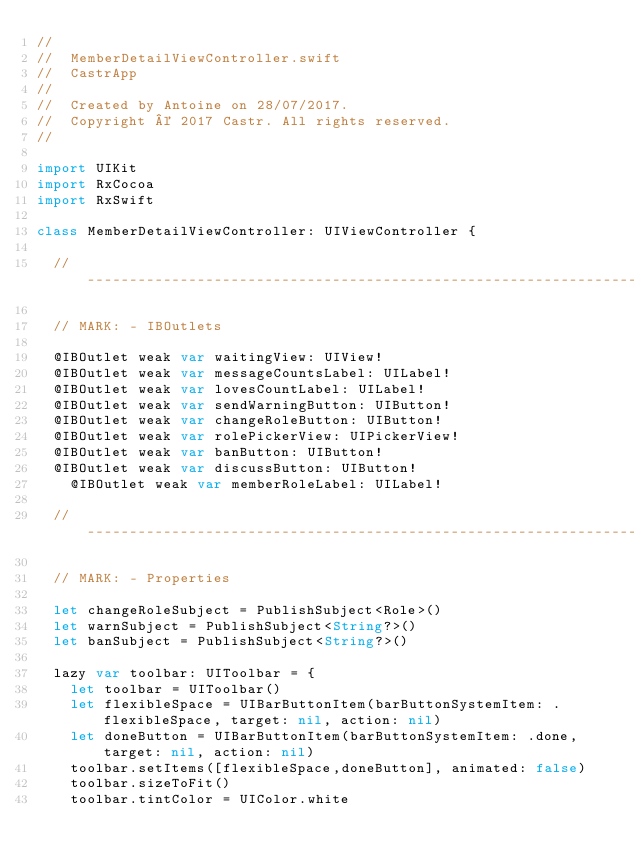<code> <loc_0><loc_0><loc_500><loc_500><_Swift_>//
//  MemberDetailViewController.swift
//  CastrApp
//
//  Created by Antoine on 28/07/2017.
//  Copyright © 2017 Castr. All rights reserved.
//

import UIKit
import RxCocoa
import RxSwift

class MemberDetailViewController: UIViewController {
  
  // -----------------------------------------------------------------------------------------------
  
  // MARK: - IBOutlets
    
  @IBOutlet weak var waitingView: UIView!
  @IBOutlet weak var messageCountsLabel: UILabel!
  @IBOutlet weak var lovesCountLabel: UILabel!
  @IBOutlet weak var sendWarningButton: UIButton!
  @IBOutlet weak var changeRoleButton: UIButton!
  @IBOutlet weak var rolePickerView: UIPickerView!
  @IBOutlet weak var banButton: UIButton!
  @IBOutlet weak var discussButton: UIButton!
    @IBOutlet weak var memberRoleLabel: UILabel!
  
  // -----------------------------------------------------------------------------------------------
    
  // MARK: - Properties
  
  let changeRoleSubject = PublishSubject<Role>()
  let warnSubject = PublishSubject<String?>()
  let banSubject = PublishSubject<String?>()

  lazy var toolbar: UIToolbar = {
    let toolbar = UIToolbar()
    let flexibleSpace = UIBarButtonItem(barButtonSystemItem: .flexibleSpace, target: nil, action: nil)
    let doneButton = UIBarButtonItem(barButtonSystemItem: .done, target: nil, action: nil)
    toolbar.setItems([flexibleSpace,doneButton], animated: false)
    toolbar.sizeToFit()
    toolbar.tintColor = UIColor.white</code> 